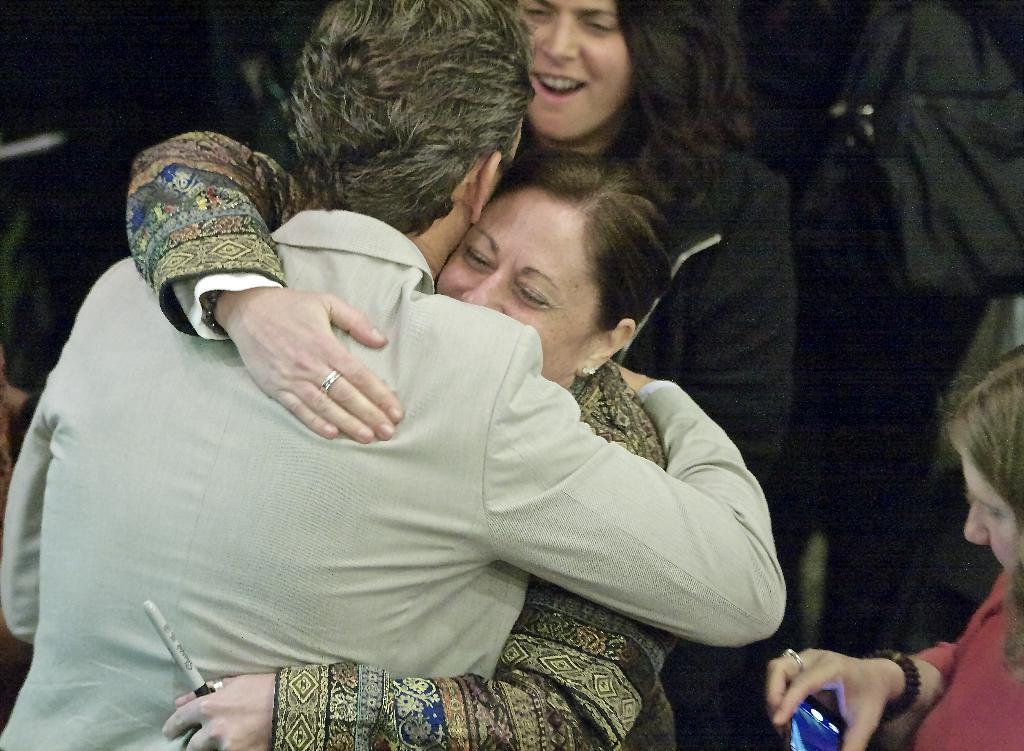How many people are in the image? There are three persons in the middle of the image. What is the woman on the right side of the image holding? The woman is holding a mobile on the right side of the image. What can be observed about the lighting in the image? The background of the image is dark. What additional item can be seen in the image? There is a bag visible in the image. What type of pan is being used by the persons in the image? There is no pan present in the image; it features three persons and a woman holding a mobile. What act are the persons performing in the image? The image does not depict any specific act or performance; it simply shows three persons and a woman holding a mobile. 